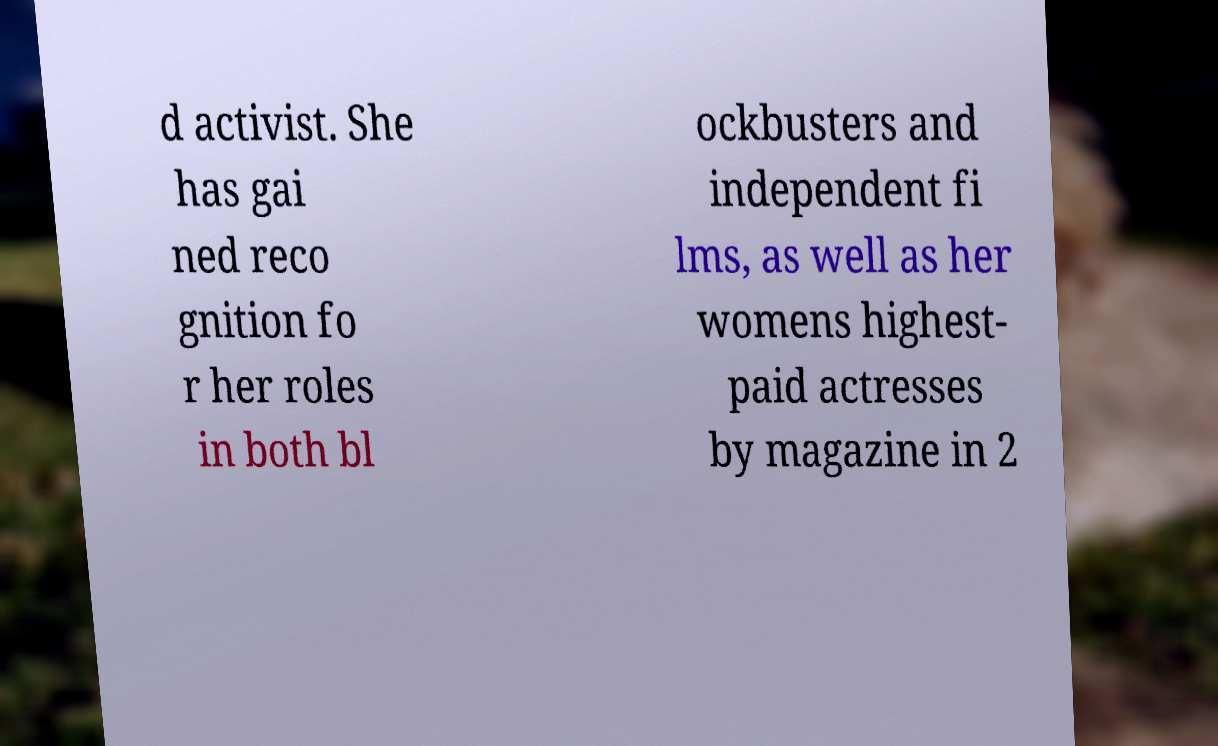What messages or text are displayed in this image? I need them in a readable, typed format. d activist. She has gai ned reco gnition fo r her roles in both bl ockbusters and independent fi lms, as well as her womens highest- paid actresses by magazine in 2 